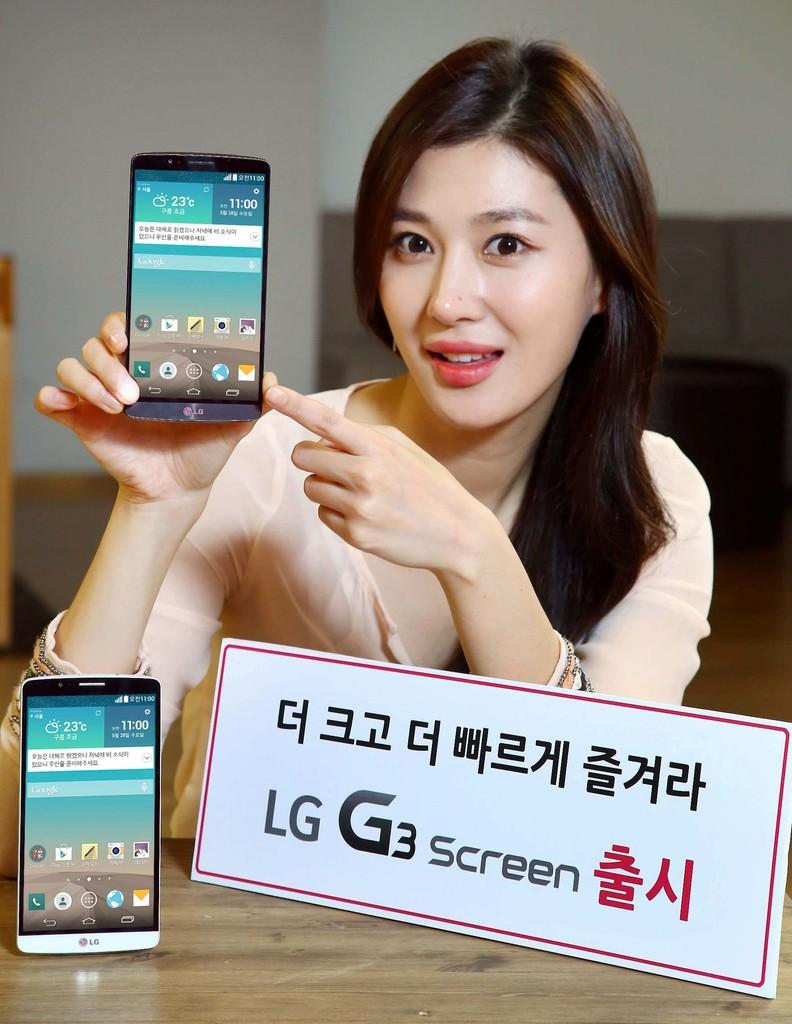Provide a one-sentence caption for the provided image. An advertisement showing a woman for the cell phone LG G3 screen. 